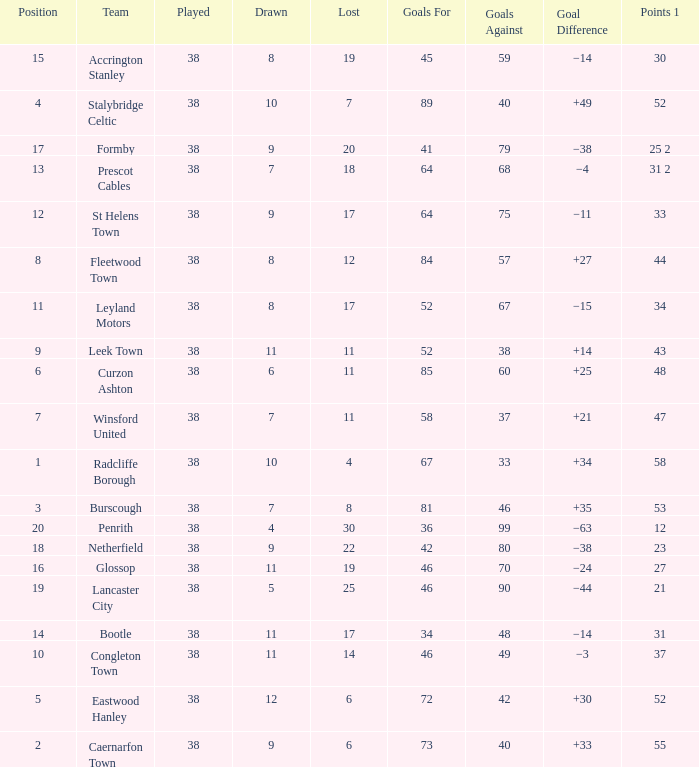WHAT GOALS AGAINST HAD A GOAL FOR OF 46, AND PLAYED LESS THAN 38? None. 